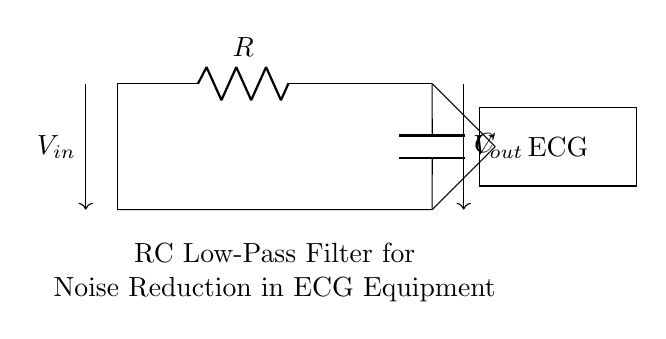What is the component labeled R? The component labeled R is a resistor, which is used to limit the current flowing in the circuit.
Answer: resistor What is the component labeled C? The component labeled C is a capacitor, which stores electrical energy temporarily and allows AC signals to pass while blocking DC signals.
Answer: capacitor What type of filter is represented in this circuit? The circuit is an RC low-pass filter, designed to reduce high-frequency noise while allowing lower frequency signals, such as an ECG signal, to pass through.
Answer: low-pass filter What is the direction of the input voltage in this circuit? The input voltage, labeled V_in, flows from the left side of the circuit to the right, entering the circuit at the node where the resistor connects.
Answer: left to right Explain the role of the capacitor in this circuit. The capacitor in this RC circuit serves to smooth out fluctuations in the input voltage, effectively filtering out high-frequency noise. When AC noise is present, the capacitor allows this noise to discharge, while the DC signals from the ECG remain mostly unaffected, thus preserving the signal integrity.
Answer: filters noise What happens to the output voltage when the frequency of the input signal increases? As the frequency of the input signal increases, the output voltage decreases because the capacitor becomes more reactive, allowing more of the higher frequency components to be shunted to ground. This reduction in output voltage helps to filter out high-frequency noise from the ECG signal.
Answer: decreases 